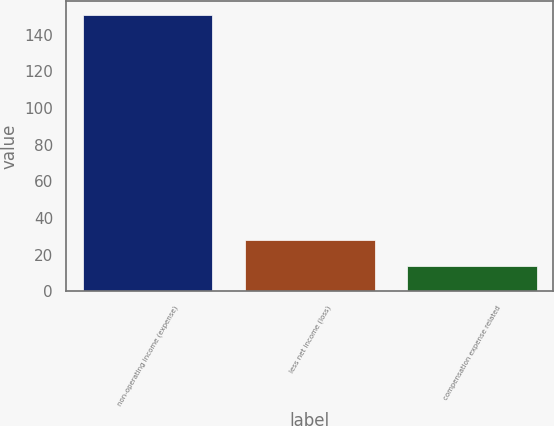Convert chart to OTSL. <chart><loc_0><loc_0><loc_500><loc_500><bar_chart><fcel>non-operating income (expense)<fcel>less net income (loss)<fcel>compensation expense related<nl><fcel>150.8<fcel>27.8<fcel>14<nl></chart> 